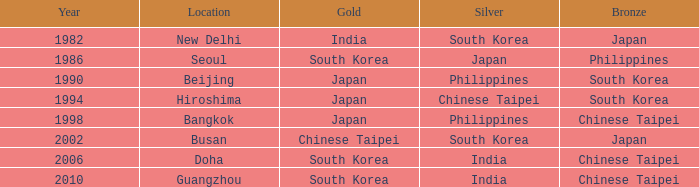Which Bronze has a Year smaller than 1994, and a Silver of south korea? Japan. 